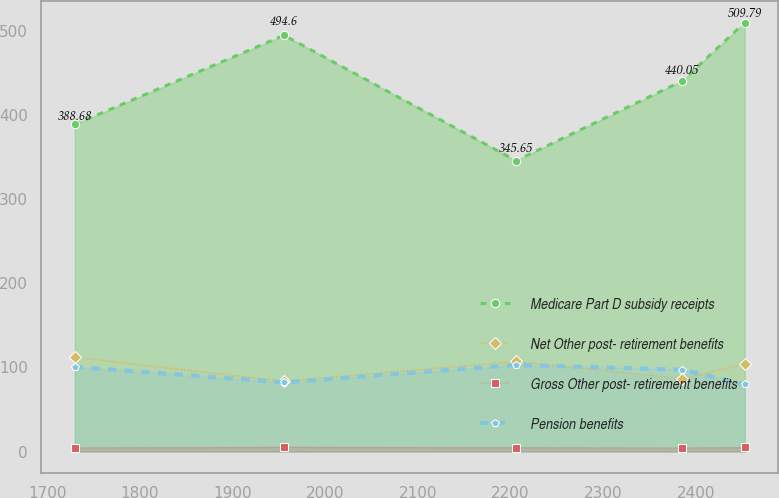Convert chart to OTSL. <chart><loc_0><loc_0><loc_500><loc_500><line_chart><ecel><fcel>Medicare Part D subsidy receipts<fcel>Net Other post- retirement benefits<fcel>Gross Other post- retirement benefits<fcel>Pension benefits<nl><fcel>1729.58<fcel>388.68<fcel>112.03<fcel>4.36<fcel>100.58<nl><fcel>1955.51<fcel>494.6<fcel>83.53<fcel>5.34<fcel>82.14<nl><fcel>2205.95<fcel>345.65<fcel>107.15<fcel>4.74<fcel>102.81<nl><fcel>2385.17<fcel>440.05<fcel>86.38<fcel>4.25<fcel>97.26<nl><fcel>2452.99<fcel>509.79<fcel>104.3<fcel>4.94<fcel>79.79<nl></chart> 